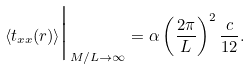<formula> <loc_0><loc_0><loc_500><loc_500>\langle t _ { x x } ( { r } ) \rangle \Big | _ { M / L \rightarrow \infty } = \alpha \left ( \frac { 2 \pi } L \right ) ^ { 2 } \frac { c } { 1 2 } .</formula> 